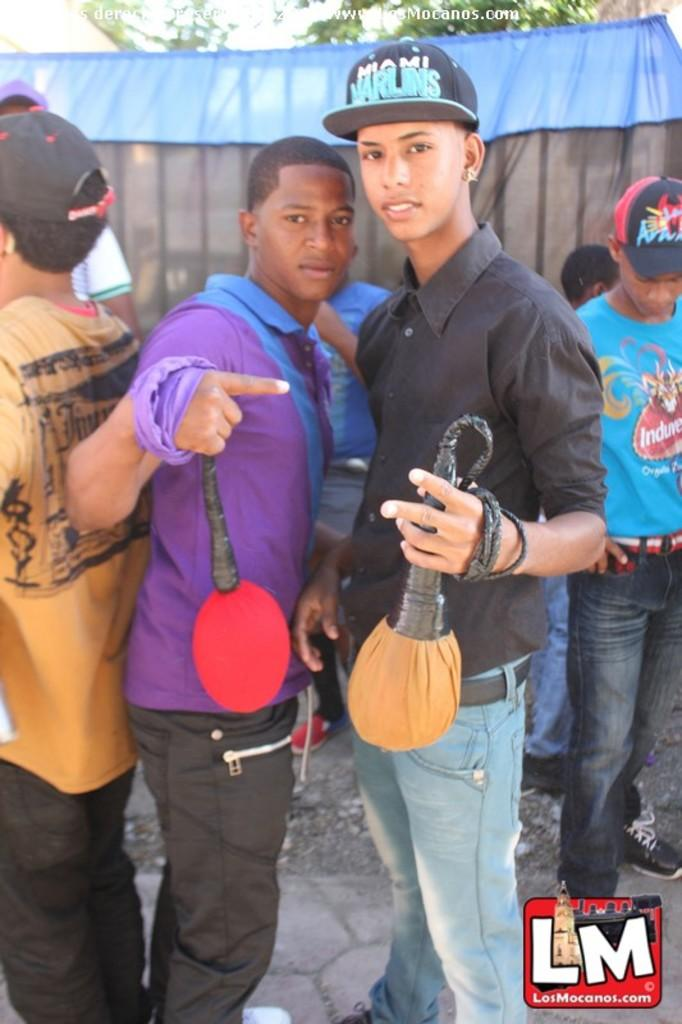How many people are in the image? There is a group of people in the image. What are the people doing in the image? The people are standing on the ground. What are the boys holding in their hands? Two boys are holding objects in their hands. What is the expression on the boys' faces? The boys are smiling. What can be seen in the background of the image? There is a cloth and leaves visible in the background. What time of day is it in the image? The provided facts do not give any information about the time of day, so it cannot be determined from the image. 